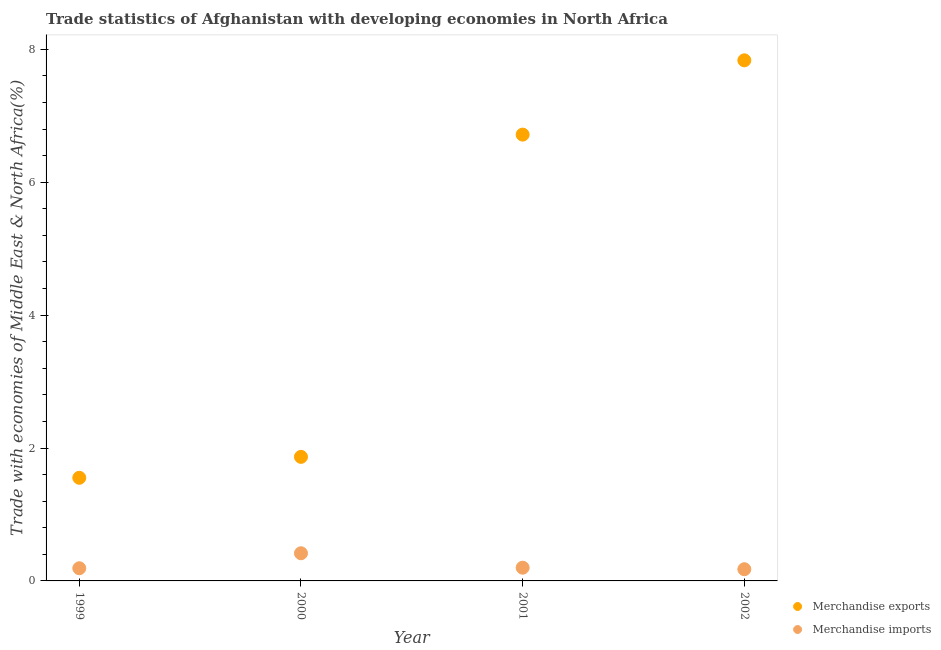Is the number of dotlines equal to the number of legend labels?
Offer a very short reply. Yes. What is the merchandise exports in 2001?
Give a very brief answer. 6.72. Across all years, what is the maximum merchandise exports?
Your answer should be very brief. 7.83. Across all years, what is the minimum merchandise imports?
Ensure brevity in your answer.  0.18. In which year was the merchandise exports maximum?
Offer a very short reply. 2002. What is the total merchandise imports in the graph?
Ensure brevity in your answer.  0.98. What is the difference between the merchandise exports in 2000 and that in 2002?
Give a very brief answer. -5.97. What is the difference between the merchandise imports in 2001 and the merchandise exports in 2002?
Offer a terse response. -7.63. What is the average merchandise imports per year?
Keep it short and to the point. 0.25. In the year 2000, what is the difference between the merchandise exports and merchandise imports?
Give a very brief answer. 1.45. In how many years, is the merchandise exports greater than 5.2 %?
Offer a terse response. 2. What is the ratio of the merchandise exports in 1999 to that in 2000?
Your answer should be compact. 0.83. What is the difference between the highest and the second highest merchandise exports?
Your response must be concise. 1.12. What is the difference between the highest and the lowest merchandise imports?
Ensure brevity in your answer.  0.24. Is the sum of the merchandise imports in 2001 and 2002 greater than the maximum merchandise exports across all years?
Provide a short and direct response. No. Is the merchandise imports strictly greater than the merchandise exports over the years?
Offer a terse response. No. Is the merchandise imports strictly less than the merchandise exports over the years?
Ensure brevity in your answer.  Yes. How many dotlines are there?
Ensure brevity in your answer.  2. How many years are there in the graph?
Your answer should be compact. 4. What is the difference between two consecutive major ticks on the Y-axis?
Keep it short and to the point. 2. How many legend labels are there?
Ensure brevity in your answer.  2. How are the legend labels stacked?
Provide a succinct answer. Vertical. What is the title of the graph?
Ensure brevity in your answer.  Trade statistics of Afghanistan with developing economies in North Africa. Does "Fixed telephone" appear as one of the legend labels in the graph?
Offer a terse response. No. What is the label or title of the X-axis?
Provide a short and direct response. Year. What is the label or title of the Y-axis?
Provide a succinct answer. Trade with economies of Middle East & North Africa(%). What is the Trade with economies of Middle East & North Africa(%) in Merchandise exports in 1999?
Your answer should be compact. 1.55. What is the Trade with economies of Middle East & North Africa(%) of Merchandise imports in 1999?
Give a very brief answer. 0.19. What is the Trade with economies of Middle East & North Africa(%) in Merchandise exports in 2000?
Your answer should be compact. 1.87. What is the Trade with economies of Middle East & North Africa(%) of Merchandise imports in 2000?
Give a very brief answer. 0.42. What is the Trade with economies of Middle East & North Africa(%) of Merchandise exports in 2001?
Make the answer very short. 6.72. What is the Trade with economies of Middle East & North Africa(%) in Merchandise imports in 2001?
Your answer should be very brief. 0.2. What is the Trade with economies of Middle East & North Africa(%) in Merchandise exports in 2002?
Offer a terse response. 7.83. What is the Trade with economies of Middle East & North Africa(%) in Merchandise imports in 2002?
Offer a terse response. 0.18. Across all years, what is the maximum Trade with economies of Middle East & North Africa(%) of Merchandise exports?
Offer a terse response. 7.83. Across all years, what is the maximum Trade with economies of Middle East & North Africa(%) of Merchandise imports?
Give a very brief answer. 0.42. Across all years, what is the minimum Trade with economies of Middle East & North Africa(%) in Merchandise exports?
Your answer should be compact. 1.55. Across all years, what is the minimum Trade with economies of Middle East & North Africa(%) of Merchandise imports?
Offer a terse response. 0.18. What is the total Trade with economies of Middle East & North Africa(%) of Merchandise exports in the graph?
Provide a succinct answer. 17.97. What is the total Trade with economies of Middle East & North Africa(%) of Merchandise imports in the graph?
Ensure brevity in your answer.  0.98. What is the difference between the Trade with economies of Middle East & North Africa(%) of Merchandise exports in 1999 and that in 2000?
Provide a succinct answer. -0.31. What is the difference between the Trade with economies of Middle East & North Africa(%) in Merchandise imports in 1999 and that in 2000?
Offer a terse response. -0.23. What is the difference between the Trade with economies of Middle East & North Africa(%) in Merchandise exports in 1999 and that in 2001?
Keep it short and to the point. -5.16. What is the difference between the Trade with economies of Middle East & North Africa(%) of Merchandise imports in 1999 and that in 2001?
Ensure brevity in your answer.  -0.01. What is the difference between the Trade with economies of Middle East & North Africa(%) of Merchandise exports in 1999 and that in 2002?
Keep it short and to the point. -6.28. What is the difference between the Trade with economies of Middle East & North Africa(%) in Merchandise imports in 1999 and that in 2002?
Keep it short and to the point. 0.01. What is the difference between the Trade with economies of Middle East & North Africa(%) of Merchandise exports in 2000 and that in 2001?
Offer a terse response. -4.85. What is the difference between the Trade with economies of Middle East & North Africa(%) of Merchandise imports in 2000 and that in 2001?
Provide a succinct answer. 0.22. What is the difference between the Trade with economies of Middle East & North Africa(%) in Merchandise exports in 2000 and that in 2002?
Provide a succinct answer. -5.97. What is the difference between the Trade with economies of Middle East & North Africa(%) of Merchandise imports in 2000 and that in 2002?
Make the answer very short. 0.24. What is the difference between the Trade with economies of Middle East & North Africa(%) in Merchandise exports in 2001 and that in 2002?
Provide a short and direct response. -1.12. What is the difference between the Trade with economies of Middle East & North Africa(%) of Merchandise imports in 2001 and that in 2002?
Offer a very short reply. 0.02. What is the difference between the Trade with economies of Middle East & North Africa(%) of Merchandise exports in 1999 and the Trade with economies of Middle East & North Africa(%) of Merchandise imports in 2000?
Your answer should be very brief. 1.14. What is the difference between the Trade with economies of Middle East & North Africa(%) in Merchandise exports in 1999 and the Trade with economies of Middle East & North Africa(%) in Merchandise imports in 2001?
Your answer should be very brief. 1.35. What is the difference between the Trade with economies of Middle East & North Africa(%) of Merchandise exports in 1999 and the Trade with economies of Middle East & North Africa(%) of Merchandise imports in 2002?
Keep it short and to the point. 1.38. What is the difference between the Trade with economies of Middle East & North Africa(%) in Merchandise exports in 2000 and the Trade with economies of Middle East & North Africa(%) in Merchandise imports in 2001?
Offer a very short reply. 1.67. What is the difference between the Trade with economies of Middle East & North Africa(%) of Merchandise exports in 2000 and the Trade with economies of Middle East & North Africa(%) of Merchandise imports in 2002?
Keep it short and to the point. 1.69. What is the difference between the Trade with economies of Middle East & North Africa(%) in Merchandise exports in 2001 and the Trade with economies of Middle East & North Africa(%) in Merchandise imports in 2002?
Ensure brevity in your answer.  6.54. What is the average Trade with economies of Middle East & North Africa(%) in Merchandise exports per year?
Your answer should be very brief. 4.49. What is the average Trade with economies of Middle East & North Africa(%) in Merchandise imports per year?
Your response must be concise. 0.25. In the year 1999, what is the difference between the Trade with economies of Middle East & North Africa(%) in Merchandise exports and Trade with economies of Middle East & North Africa(%) in Merchandise imports?
Ensure brevity in your answer.  1.36. In the year 2000, what is the difference between the Trade with economies of Middle East & North Africa(%) in Merchandise exports and Trade with economies of Middle East & North Africa(%) in Merchandise imports?
Your answer should be compact. 1.45. In the year 2001, what is the difference between the Trade with economies of Middle East & North Africa(%) in Merchandise exports and Trade with economies of Middle East & North Africa(%) in Merchandise imports?
Provide a succinct answer. 6.52. In the year 2002, what is the difference between the Trade with economies of Middle East & North Africa(%) of Merchandise exports and Trade with economies of Middle East & North Africa(%) of Merchandise imports?
Provide a succinct answer. 7.66. What is the ratio of the Trade with economies of Middle East & North Africa(%) in Merchandise exports in 1999 to that in 2000?
Offer a terse response. 0.83. What is the ratio of the Trade with economies of Middle East & North Africa(%) of Merchandise imports in 1999 to that in 2000?
Your response must be concise. 0.46. What is the ratio of the Trade with economies of Middle East & North Africa(%) in Merchandise exports in 1999 to that in 2001?
Your answer should be very brief. 0.23. What is the ratio of the Trade with economies of Middle East & North Africa(%) in Merchandise imports in 1999 to that in 2001?
Make the answer very short. 0.96. What is the ratio of the Trade with economies of Middle East & North Africa(%) of Merchandise exports in 1999 to that in 2002?
Your response must be concise. 0.2. What is the ratio of the Trade with economies of Middle East & North Africa(%) of Merchandise imports in 1999 to that in 2002?
Provide a succinct answer. 1.08. What is the ratio of the Trade with economies of Middle East & North Africa(%) in Merchandise exports in 2000 to that in 2001?
Your response must be concise. 0.28. What is the ratio of the Trade with economies of Middle East & North Africa(%) of Merchandise imports in 2000 to that in 2001?
Keep it short and to the point. 2.09. What is the ratio of the Trade with economies of Middle East & North Africa(%) in Merchandise exports in 2000 to that in 2002?
Offer a very short reply. 0.24. What is the ratio of the Trade with economies of Middle East & North Africa(%) in Merchandise imports in 2000 to that in 2002?
Make the answer very short. 2.36. What is the ratio of the Trade with economies of Middle East & North Africa(%) of Merchandise exports in 2001 to that in 2002?
Your response must be concise. 0.86. What is the ratio of the Trade with economies of Middle East & North Africa(%) of Merchandise imports in 2001 to that in 2002?
Offer a terse response. 1.13. What is the difference between the highest and the second highest Trade with economies of Middle East & North Africa(%) in Merchandise exports?
Offer a very short reply. 1.12. What is the difference between the highest and the second highest Trade with economies of Middle East & North Africa(%) in Merchandise imports?
Provide a short and direct response. 0.22. What is the difference between the highest and the lowest Trade with economies of Middle East & North Africa(%) of Merchandise exports?
Your answer should be compact. 6.28. What is the difference between the highest and the lowest Trade with economies of Middle East & North Africa(%) of Merchandise imports?
Your answer should be compact. 0.24. 